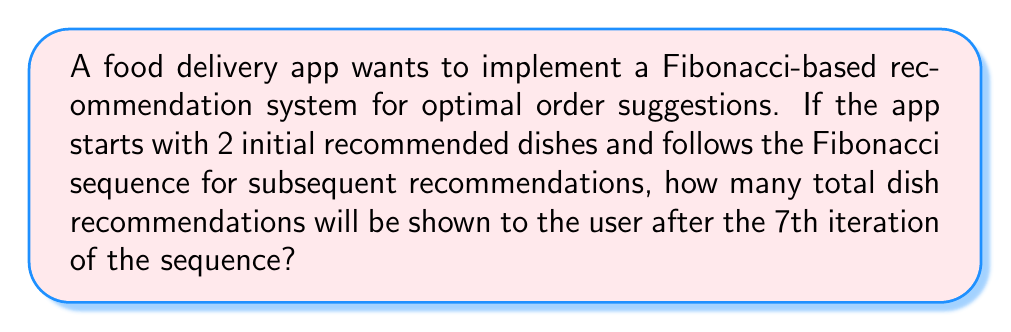Can you answer this question? Let's approach this step-by-step:

1) The Fibonacci sequence starts with two numbers, typically 0 and 1, or 1 and 1. In this case, we start with 2 initial dishes, so our first two terms are:

   $F_1 = 1$, $F_2 = 1$

2) The subsequent terms are found by adding the two preceding terms:

   $F_3 = F_1 + F_2 = 1 + 1 = 2$
   $F_4 = F_2 + F_3 = 1 + 2 = 3$
   $F_5 = F_3 + F_4 = 2 + 3 = 5$
   $F_6 = F_4 + F_5 = 3 + 5 = 8$
   $F_7 = F_5 + F_6 = 5 + 8 = 13$

3) Now, we need to sum all these terms to get the total number of recommendations:

   $\text{Total} = F_1 + F_2 + F_3 + F_4 + F_5 + F_6 + F_7$

4) Substituting the values:

   $\text{Total} = 1 + 1 + 2 + 3 + 5 + 8 + 13$

5) Summing up:

   $\text{Total} = 33$

6) Finally, we add the 2 initial recommended dishes:

   $\text{Final Total} = 33 + 2 = 35$

Therefore, after the 7th iteration, the app will have shown a total of 35 dish recommendations to the user.
Answer: 35 